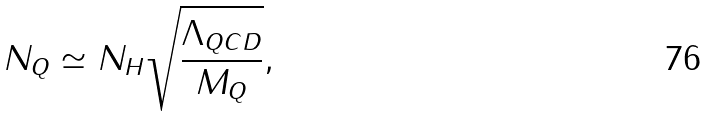Convert formula to latex. <formula><loc_0><loc_0><loc_500><loc_500>N _ { Q } \simeq N _ { H } \sqrt { \frac { \Lambda _ { Q C D } } { M _ { Q } } } ,</formula> 